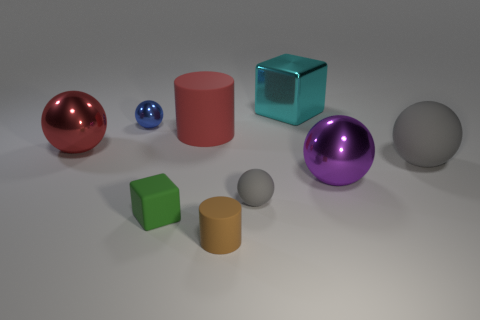There is a ball that is the same color as the big cylinder; what size is it?
Keep it short and to the point. Large. What color is the large rubber thing that is on the right side of the big shiny block?
Offer a very short reply. Gray. There is a small matte sphere; is it the same color as the big rubber thing that is to the right of the brown thing?
Make the answer very short. Yes. Is the number of cylinders less than the number of big cylinders?
Your answer should be compact. No. There is a tiny matte sphere that is to the right of the tiny blue metallic thing; does it have the same color as the large rubber ball?
Make the answer very short. Yes. What number of yellow metallic objects are the same size as the purple metallic sphere?
Your response must be concise. 0. Is there a thing that has the same color as the big rubber ball?
Keep it short and to the point. Yes. Do the tiny cube and the cyan cube have the same material?
Keep it short and to the point. No. How many big cyan metallic objects are the same shape as the green thing?
Ensure brevity in your answer.  1. There is a big red object that is made of the same material as the small gray sphere; what shape is it?
Provide a succinct answer. Cylinder. 